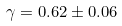<formula> <loc_0><loc_0><loc_500><loc_500>\gamma = 0 . 6 2 \pm 0 . 0 6</formula> 